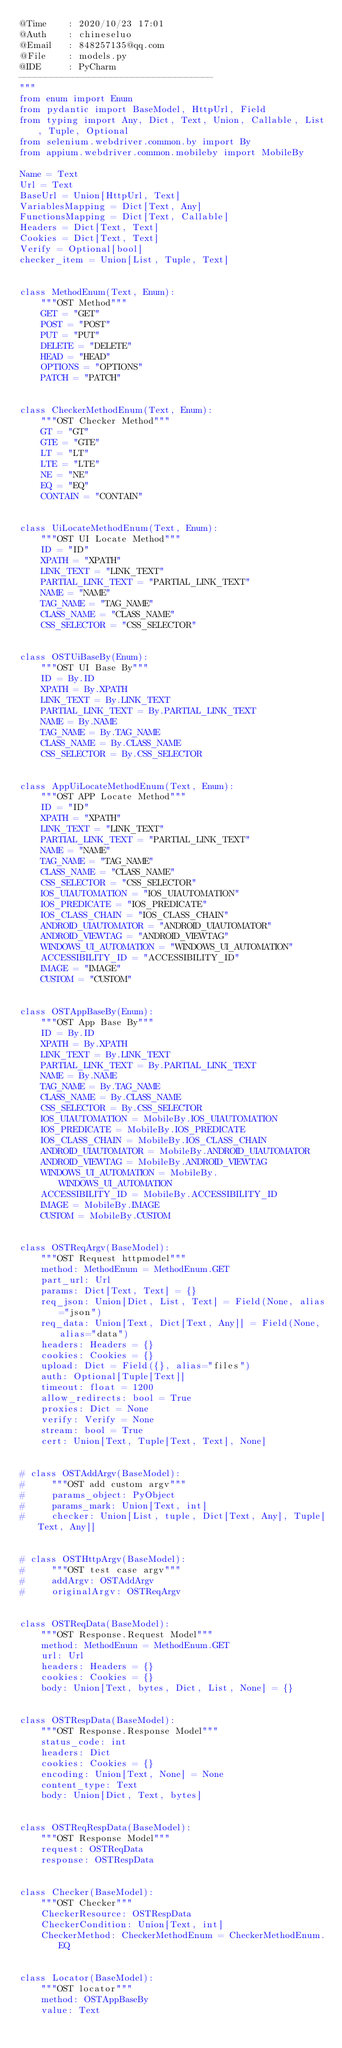Convert code to text. <code><loc_0><loc_0><loc_500><loc_500><_Python_>@Time    : 2020/10/23 17:01
@Auth    : chineseluo
@Email   : 848257135@qq.com
@File    : models.py
@IDE     : PyCharm
------------------------------------
"""
from enum import Enum
from pydantic import BaseModel, HttpUrl, Field
from typing import Any, Dict, Text, Union, Callable, List, Tuple, Optional
from selenium.webdriver.common.by import By
from appium.webdriver.common.mobileby import MobileBy

Name = Text
Url = Text
BaseUrl = Union[HttpUrl, Text]
VariablesMapping = Dict[Text, Any]
FunctionsMapping = Dict[Text, Callable]
Headers = Dict[Text, Text]
Cookies = Dict[Text, Text]
Verify = Optional[bool]
checker_item = Union[List, Tuple, Text]


class MethodEnum(Text, Enum):
    """OST Method"""
    GET = "GET"
    POST = "POST"
    PUT = "PUT"
    DELETE = "DELETE"
    HEAD = "HEAD"
    OPTIONS = "OPTIONS"
    PATCH = "PATCH"


class CheckerMethodEnum(Text, Enum):
    """OST Checker Method"""
    GT = "GT"
    GTE = "GTE"
    LT = "LT"
    LTE = "LTE"
    NE = "NE"
    EQ = "EQ"
    CONTAIN = "CONTAIN"


class UiLocateMethodEnum(Text, Enum):
    """OST UI Locate Method"""
    ID = "ID"
    XPATH = "XPATH"
    LINK_TEXT = "LINK_TEXT"
    PARTIAL_LINK_TEXT = "PARTIAL_LINK_TEXT"
    NAME = "NAME"
    TAG_NAME = "TAG_NAME"
    CLASS_NAME = "CLASS_NAME"
    CSS_SELECTOR = "CSS_SELECTOR"


class OSTUiBaseBy(Enum):
    """OST UI Base By"""
    ID = By.ID
    XPATH = By.XPATH
    LINK_TEXT = By.LINK_TEXT
    PARTIAL_LINK_TEXT = By.PARTIAL_LINK_TEXT
    NAME = By.NAME
    TAG_NAME = By.TAG_NAME
    CLASS_NAME = By.CLASS_NAME
    CSS_SELECTOR = By.CSS_SELECTOR


class AppUiLocateMethodEnum(Text, Enum):
    """OST APP Locate Method"""
    ID = "ID"
    XPATH = "XPATH"
    LINK_TEXT = "LINK_TEXT"
    PARTIAL_LINK_TEXT = "PARTIAL_LINK_TEXT"
    NAME = "NAME"
    TAG_NAME = "TAG_NAME"
    CLASS_NAME = "CLASS_NAME"
    CSS_SELECTOR = "CSS_SELECTOR"
    IOS_UIAUTOMATION = "IOS_UIAUTOMATION"
    IOS_PREDICATE = "IOS_PREDICATE"
    IOS_CLASS_CHAIN = "IOS_CLASS_CHAIN"
    ANDROID_UIAUTOMATOR = "ANDROID_UIAUTOMATOR"
    ANDROID_VIEWTAG = "ANDROID_VIEWTAG"
    WINDOWS_UI_AUTOMATION = "WINDOWS_UI_AUTOMATION"
    ACCESSIBILITY_ID = "ACCESSIBILITY_ID"
    IMAGE = "IMAGE"
    CUSTOM = "CUSTOM"


class OSTAppBaseBy(Enum):
    """OST App Base By"""
    ID = By.ID
    XPATH = By.XPATH
    LINK_TEXT = By.LINK_TEXT
    PARTIAL_LINK_TEXT = By.PARTIAL_LINK_TEXT
    NAME = By.NAME
    TAG_NAME = By.TAG_NAME
    CLASS_NAME = By.CLASS_NAME
    CSS_SELECTOR = By.CSS_SELECTOR
    IOS_UIAUTOMATION = MobileBy.IOS_UIAUTOMATION
    IOS_PREDICATE = MobileBy.IOS_PREDICATE
    IOS_CLASS_CHAIN = MobileBy.IOS_CLASS_CHAIN
    ANDROID_UIAUTOMATOR = MobileBy.ANDROID_UIAUTOMATOR
    ANDROID_VIEWTAG = MobileBy.ANDROID_VIEWTAG
    WINDOWS_UI_AUTOMATION = MobileBy.WINDOWS_UI_AUTOMATION
    ACCESSIBILITY_ID = MobileBy.ACCESSIBILITY_ID
    IMAGE = MobileBy.IMAGE
    CUSTOM = MobileBy.CUSTOM


class OSTReqArgv(BaseModel):
    """OST Request httpmodel"""
    method: MethodEnum = MethodEnum.GET
    part_url: Url
    params: Dict[Text, Text] = {}
    req_json: Union[Dict, List, Text] = Field(None, alias="json")
    req_data: Union[Text, Dict[Text, Any]] = Field(None, alias="data")
    headers: Headers = {}
    cookies: Cookies = {}
    upload: Dict = Field({}, alias="files")
    auth: Optional[Tuple[Text]]
    timeout: float = 1200
    allow_redirects: bool = True
    proxies: Dict = None
    verify: Verify = None
    stream: bool = True
    cert: Union[Text, Tuple[Text, Text], None]


# class OSTAddArgv(BaseModel):
#     """OST add custom argv"""
#     params_object: PyObject
#     params_mark: Union[Text, int]
#     checker: Union[List, tuple, Dict[Text, Any], Tuple[Text, Any]]


# class OSTHttpArgv(BaseModel):
#     """OST test case argv"""
#     addArgv: OSTAddArgv
#     originalArgv: OSTReqArgv


class OSTReqData(BaseModel):
    """OST Response.Request Model"""
    method: MethodEnum = MethodEnum.GET
    url: Url
    headers: Headers = {}
    cookies: Cookies = {}
    body: Union[Text, bytes, Dict, List, None] = {}


class OSTRespData(BaseModel):
    """OST Response.Response Model"""
    status_code: int
    headers: Dict
    cookies: Cookies = {}
    encoding: Union[Text, None] = None
    content_type: Text
    body: Union[Dict, Text, bytes]


class OSTReqRespData(BaseModel):
    """OST Response Model"""
    request: OSTReqData
    response: OSTRespData


class Checker(BaseModel):
    """OST Checker"""
    CheckerResource: OSTRespData
    CheckerCondition: Union[Text, int]
    CheckerMethod: CheckerMethodEnum = CheckerMethodEnum.EQ


class Locator(BaseModel):
    """OST locator"""
    method: OSTAppBaseBy
    value: Text
</code> 